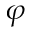Convert formula to latex. <formula><loc_0><loc_0><loc_500><loc_500>\varphi</formula> 